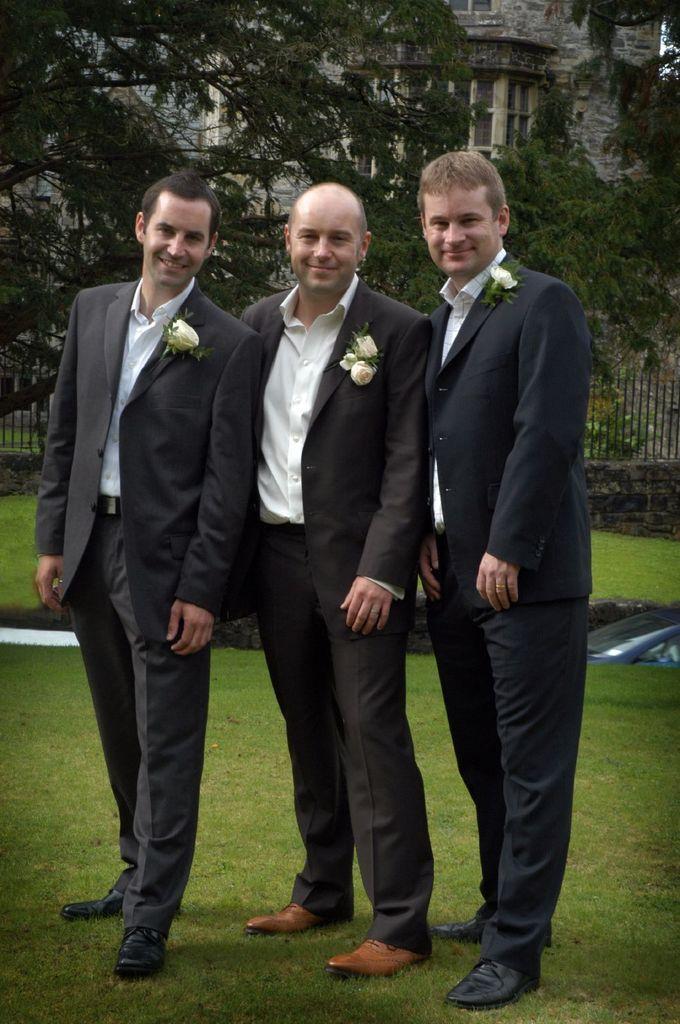How would you summarize this image in a sentence or two? In the picture we can see three men are standing on the grass surface, they are wearing blazers, shirts and a flower to their blazers and in the background we can see some trees and a building wall with a window. 